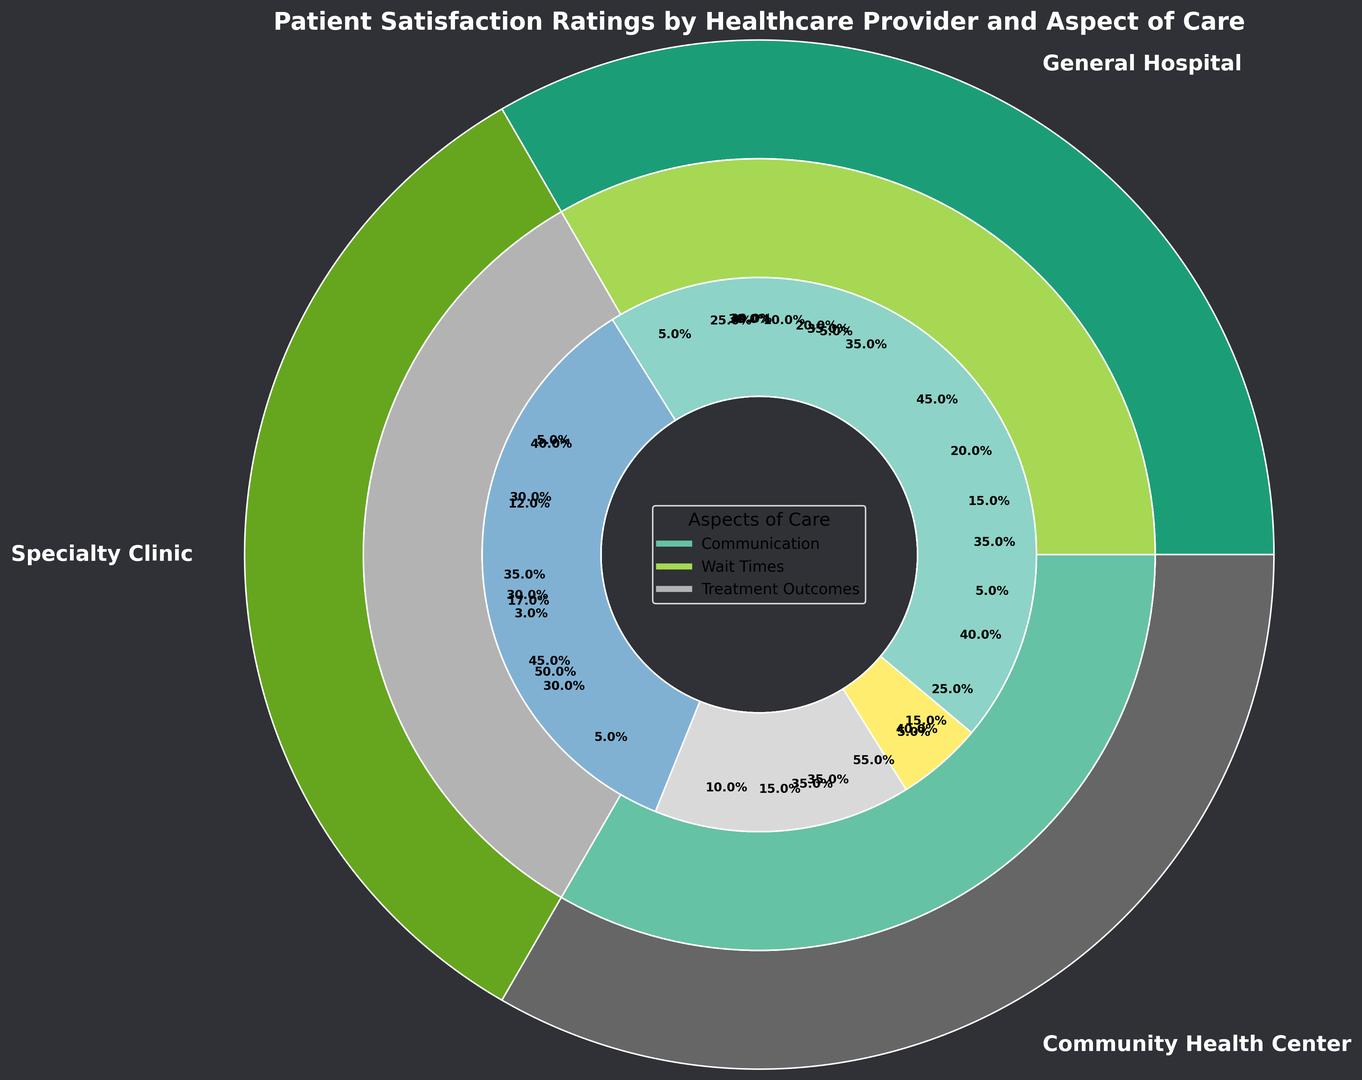Comparing Wait Times, which provider has the most Fair ratings? Compare the "Wait Times" sections across providers and find the one with the largest part colored for "Fair." General Hospital has the highest percentage for "Fair" (35%).
Answer: General Hospital What is the sum of the percentages of Excellent ratings for Communication across all healthcare providers? Sum the Excellent ratings for Communication from General Hospital (35%), Specialty Clinic (50%), and Community Health Center (40%). Therefore, 35% + 50% + 40% = 125%.
Answer: 125% Which healthcare provider has the lowest percentage of Poor ratings for Treatment Outcomes? Look at the "Treatment Outcomes" sections and find the provider with the smallest "Poor" segment. Specialty Clinic has the lowest percentage at 3%.
Answer: Specialty Clinic How do the percentages of Good ratings for Wait Times compare between General Hospital and Community Health Center? Compare the Good ratings for Wait Times: General Hospital has 30%, while Community Health Center has 35%. Community Health Center's percentage is higher.
Answer: Community Health Center What are the total Poor ratings for General Hospital across all aspects of care? Add up the Poor ratings for General Hospital across Communication (5%), Wait Times (15%), and Treatment Outcomes (5%). The total is 5% + 15% + 5% = 25%.
Answer: 25% Which aspect of care at the Community Health Center has the highest Excellent rating? Check the "Excellent" sections within Community Health Center for Communication (40%), Wait Times (25%), and Treatment Outcomes (45%). Treatment Outcomes has the highest at 45%.
Answer: Treatment Outcomes Between General Hospital and Specialty Clinic, which has a higher combined percentage of Good ratings for Communication and Treatment Outcomes? Add the Good ratings for Communication and Treatment Outcomes for both hospitals: General Hospital: 45% (Communication) + 35% (Treatment Outcomes) = 80%, Specialty Clinic: 35% (Communication) + 30% (Treatment Outcomes) = 65%. General Hospital's is higher.
Answer: General Hospital What is the average percentage of Fair ratings for Wait Times across all healthcare providers? Calculate the average of Fair ratings for Wait Times across General Hospital (35%), Specialty Clinic (25%), and Community Health Center (30%): (35% + 25% + 30%) / 3 = 30%.
Answer: 30% 